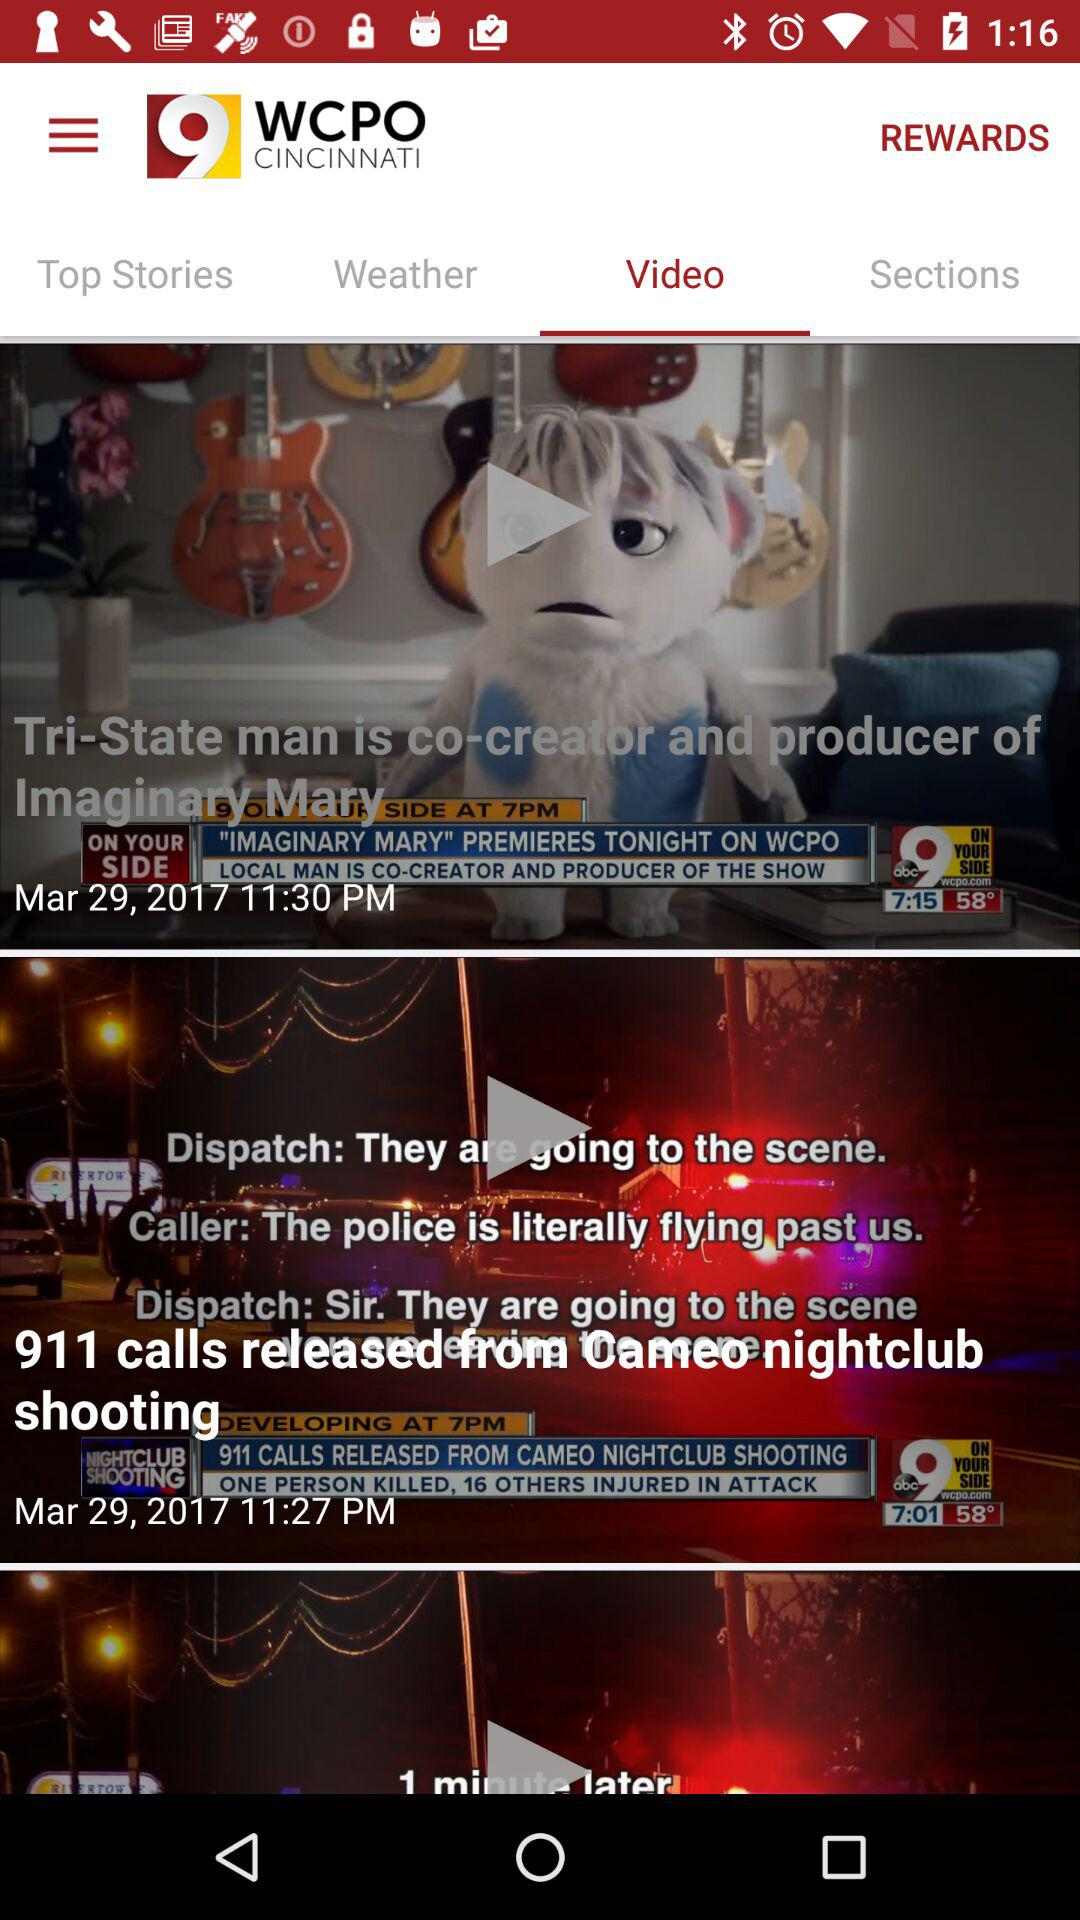Who is the co-creator and producer of Imaginary Mary? The co-creator and producer of Imaginary Mary is Tri-State man. 